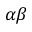Convert formula to latex. <formula><loc_0><loc_0><loc_500><loc_500>\alpha \beta</formula> 